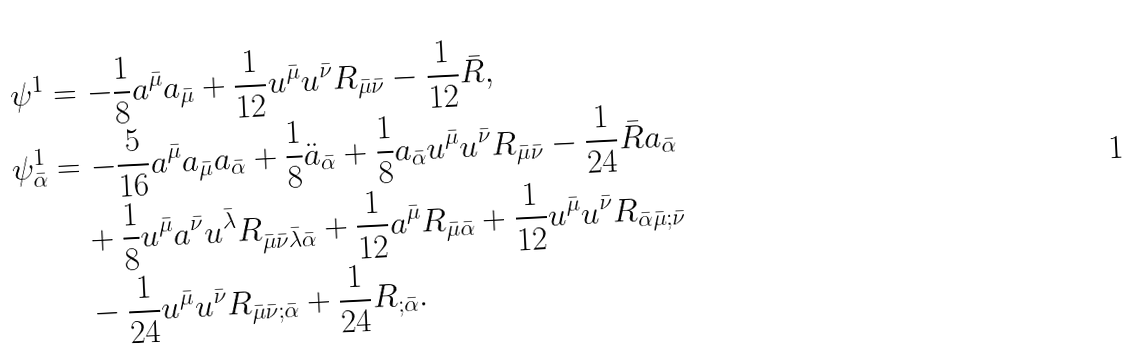Convert formula to latex. <formula><loc_0><loc_0><loc_500><loc_500>\psi ^ { 1 } & = - \frac { 1 } { 8 } a ^ { \bar { \mu } } a _ { \bar { \mu } } + \frac { 1 } { 1 2 } u ^ { \bar { \mu } } u ^ { \bar { \nu } } R _ { \bar { \mu } \bar { \nu } } - \frac { 1 } { 1 2 } \bar { R } , \\ \psi ^ { 1 } _ { \bar { \alpha } } & = - \frac { 5 } { 1 6 } a ^ { \bar { \mu } } a _ { \bar { \mu } } a _ { \bar { \alpha } } + \frac { 1 } { 8 } \ddot { a } _ { \bar { \alpha } } + \frac { 1 } { 8 } a _ { \bar { \alpha } } u ^ { \bar { \mu } } u ^ { \bar { \nu } } R _ { \bar { \mu } \bar { \nu } } - \frac { 1 } { 2 4 } \bar { R } a _ { \bar { \alpha } } \\ & \quad + \frac { 1 } { 8 } u ^ { \bar { \mu } } a ^ { \bar { \nu } } u ^ { \bar { \lambda } } R _ { \bar { \mu } \bar { \nu } \bar { \lambda } \bar { \alpha } } + \frac { 1 } { 1 2 } a ^ { \bar { \mu } } R _ { \bar { \mu } \bar { \alpha } } + \frac { 1 } { 1 2 } u ^ { \bar { \mu } } u ^ { \bar { \nu } } R _ { \bar { \alpha } \bar { \mu } ; \bar { \nu } } \\ & \quad - \frac { 1 } { 2 4 } u ^ { \bar { \mu } } u ^ { \bar { \nu } } R _ { \bar { \mu } \bar { \nu } ; \bar { \alpha } } + \frac { 1 } { 2 4 } R _ { ; \bar { \alpha } } .</formula> 